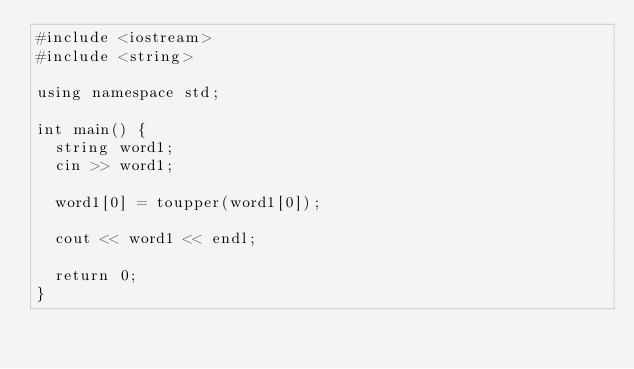<code> <loc_0><loc_0><loc_500><loc_500><_C++_>#include <iostream>
#include <string>

using namespace std;

int main() {
	string word1;
	cin >> word1;

	word1[0] = toupper(word1[0]);

	cout << word1 << endl;

	return 0;
}
</code> 